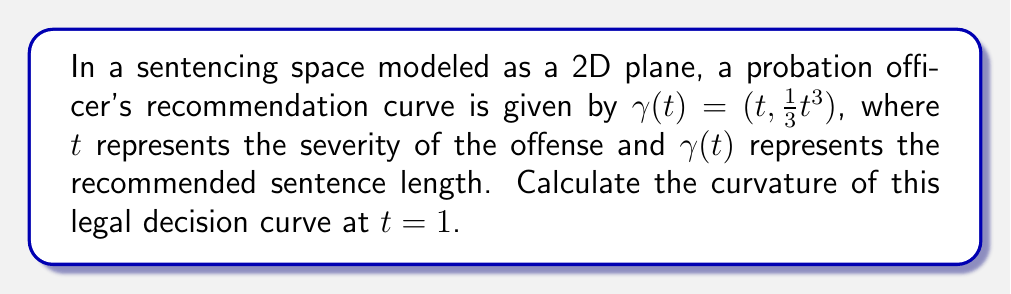Can you answer this question? To calculate the curvature of the legal decision curve, we'll follow these steps:

1) The curvature $\kappa$ of a plane curve $\gamma(t) = (x(t), y(t))$ is given by:

   $$\kappa = \frac{|x'y'' - y'x''|}{(x'^2 + y'^2)^{3/2}}$$

2) For our curve $\gamma(t) = (t, \frac{1}{3}t^3)$, we have:
   $x(t) = t$
   $y(t) = \frac{1}{3}t^3$

3) Calculate the first derivatives:
   $x'(t) = 1$
   $y'(t) = t^2$

4) Calculate the second derivatives:
   $x''(t) = 0$
   $y''(t) = 2t$

5) Substitute these into the curvature formula:

   $$\kappa = \frac{|1 \cdot 2t - t^2 \cdot 0|}{(1^2 + t^4)^{3/2}}$$

6) Simplify:

   $$\kappa = \frac{2t}{(1 + t^4)^{3/2}}$$

7) Now, we evaluate this at $t = 1$:

   $$\kappa(1) = \frac{2}{(1 + 1)^{3/2}} = \frac{2}{2^{3/2}} = \frac{2}{2\sqrt{2}} = \frac{1}{\sqrt{2}}$$
Answer: $\frac{1}{\sqrt{2}}$ 